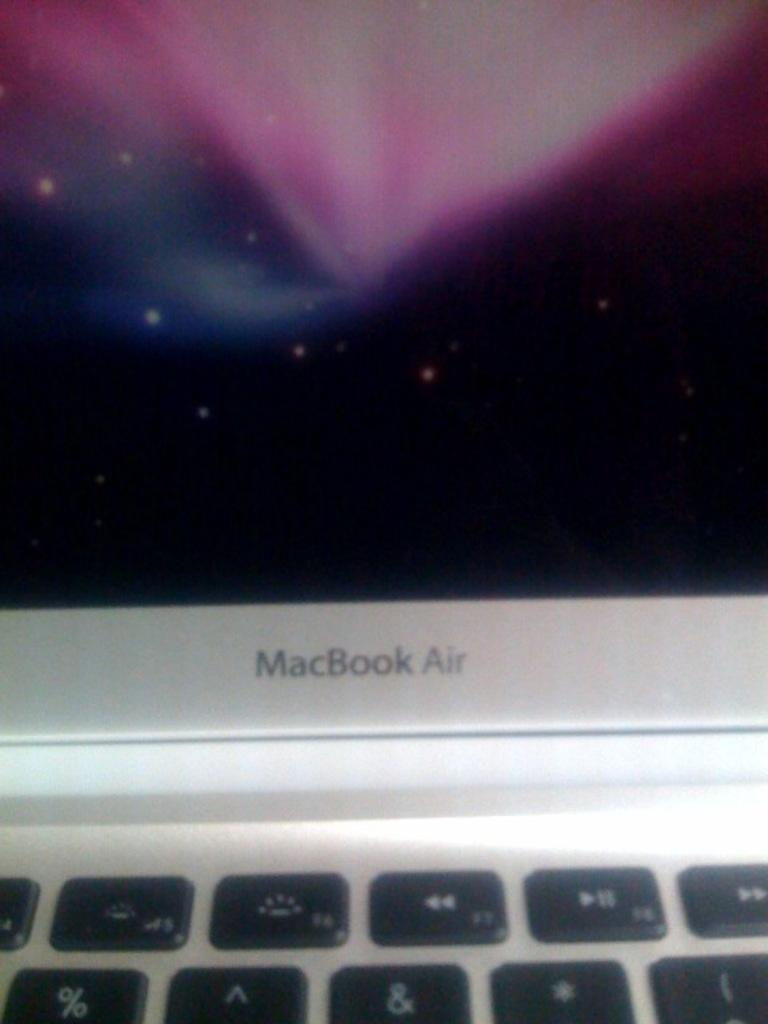Provide a one-sentence caption for the provided image. Bottom part of a gray MacBook Air monitor. 